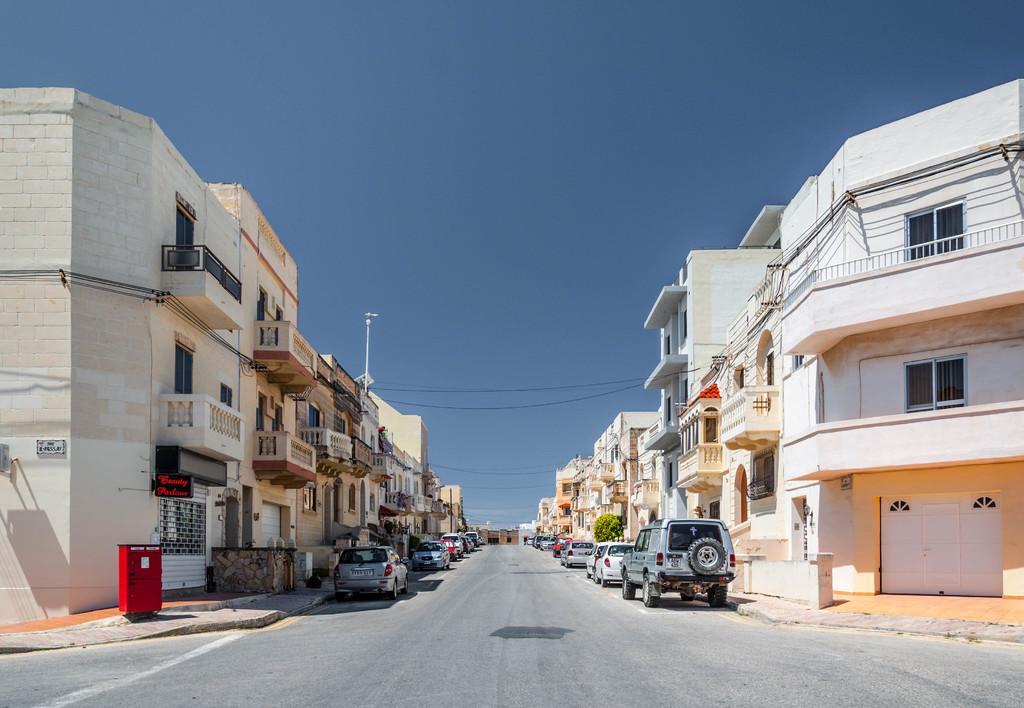Please provide a concise description of this image. In this image on the left and right side, I can see the buildings and the vehicles. I can see the road. At the top I can see the sky. 